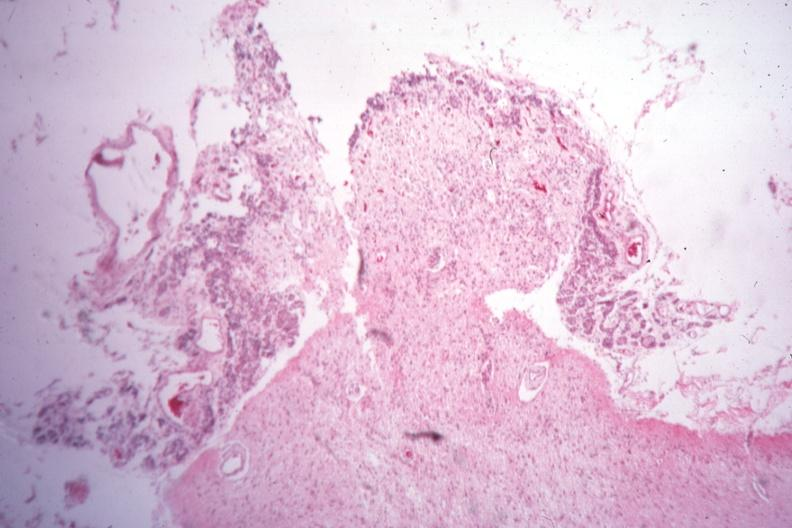what is present?
Answer the question using a single word or phrase. Pituitectomy 